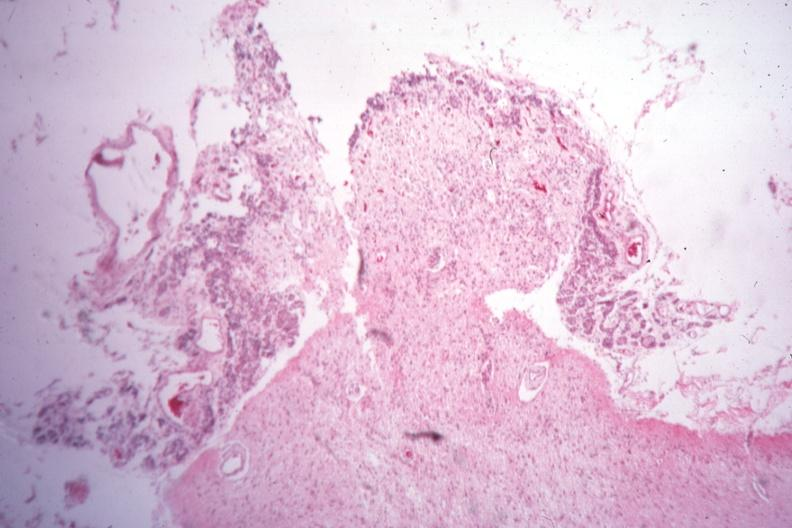what is present?
Answer the question using a single word or phrase. Pituitectomy 